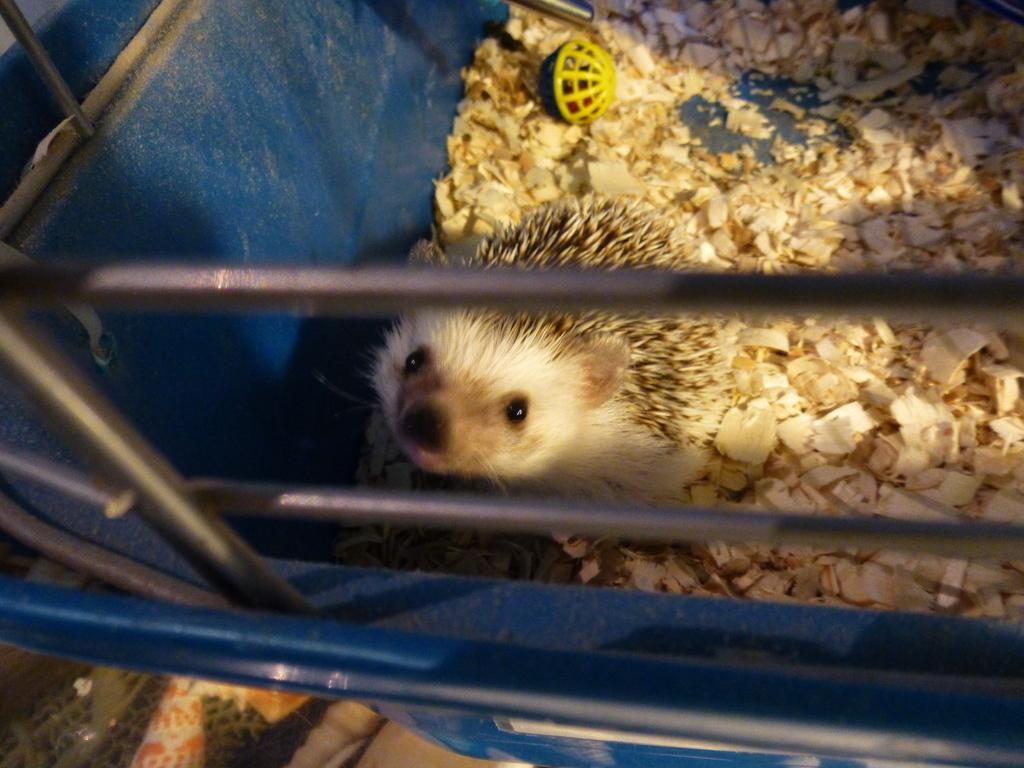What object can be seen in the image? There is a basket in the image. What is inside the basket? There is a mouse inside the basket. What else can be found in the basket besides the mouse? There is some stuff in the basket. Can you tell me how the mouse is using its sense of flight to navigate the basket? There is no mention of the mouse having the ability to fly in the image, so it cannot be determined how it might navigate the basket using flight. 